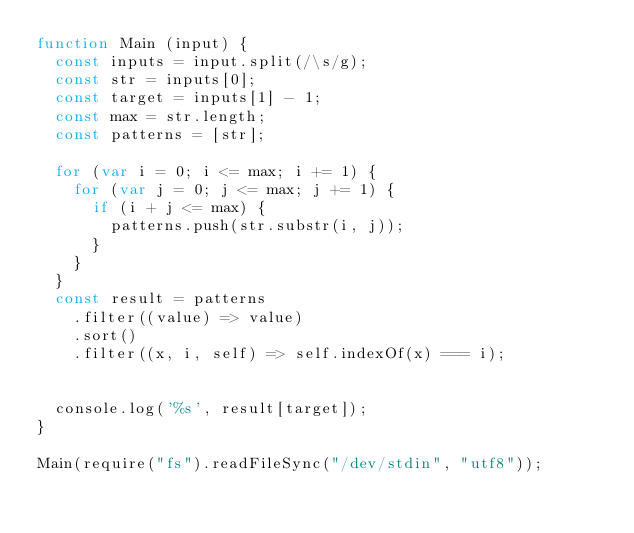<code> <loc_0><loc_0><loc_500><loc_500><_JavaScript_>function Main (input) {
  const inputs = input.split(/\s/g);
  const str = inputs[0];
  const target = inputs[1] - 1;
  const max = str.length;
  const patterns = [str];

  for (var i = 0; i <= max; i += 1) {
    for (var j = 0; j <= max; j += 1) {
      if (i + j <= max) {
        patterns.push(str.substr(i, j));
      }
    }
  }
  const result = patterns
    .filter((value) => value)
    .sort()
    .filter((x, i, self) => self.indexOf(x) === i);


  console.log('%s', result[target]);
}

Main(require("fs").readFileSync("/dev/stdin", "utf8"));
</code> 